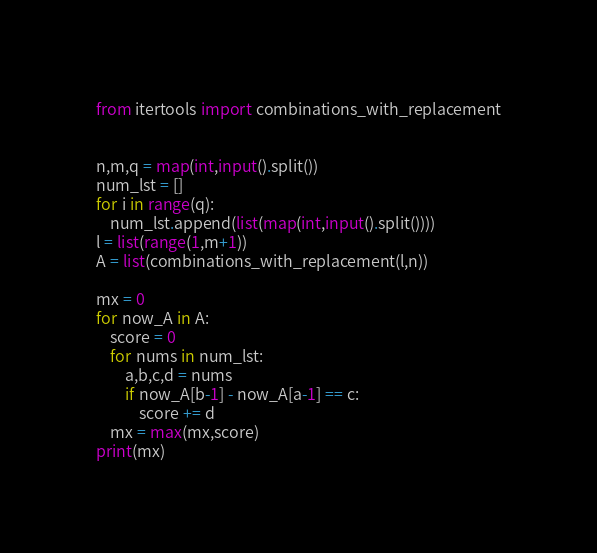Convert code to text. <code><loc_0><loc_0><loc_500><loc_500><_Python_>from itertools import combinations_with_replacement


n,m,q = map(int,input().split())
num_lst = []
for i in range(q):
    num_lst.append(list(map(int,input().split())))
l = list(range(1,m+1))
A = list(combinations_with_replacement(l,n))

mx = 0
for now_A in A:
    score = 0
    for nums in num_lst:
        a,b,c,d = nums
        if now_A[b-1] - now_A[a-1] == c:
            score += d
    mx = max(mx,score)
print(mx)



</code> 